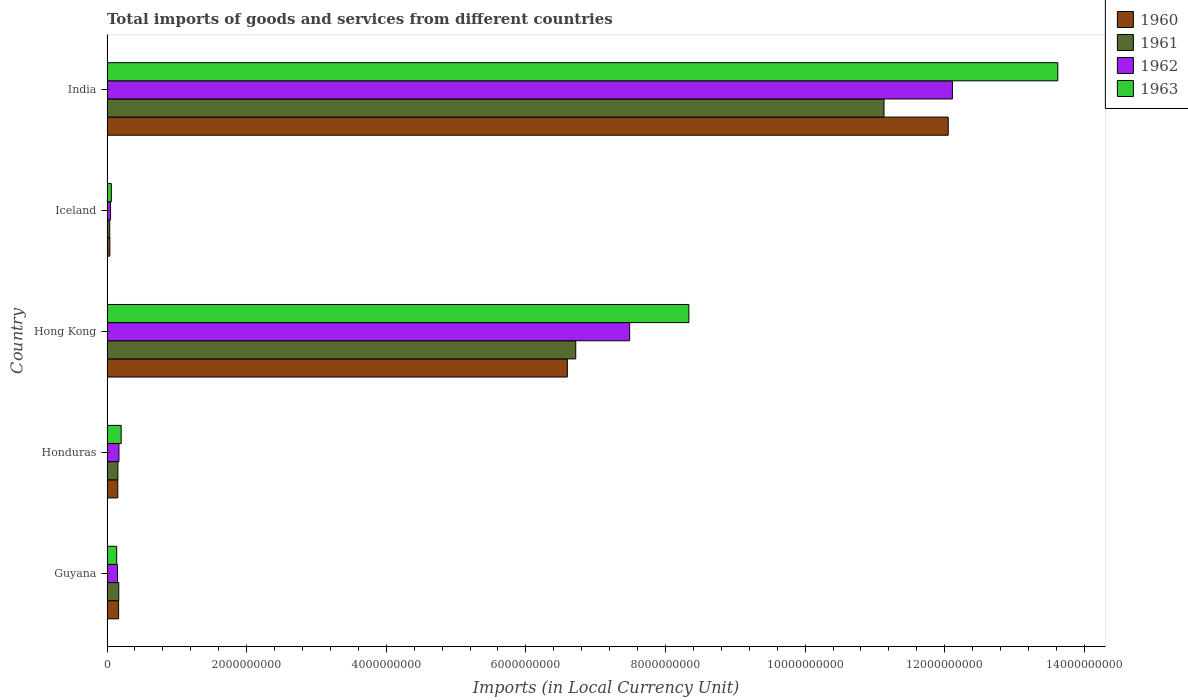How many groups of bars are there?
Offer a terse response. 5. Are the number of bars per tick equal to the number of legend labels?
Offer a very short reply. Yes. How many bars are there on the 2nd tick from the top?
Your response must be concise. 4. What is the label of the 5th group of bars from the top?
Offer a very short reply. Guyana. What is the Amount of goods and services imports in 1961 in Honduras?
Offer a terse response. 1.56e+08. Across all countries, what is the maximum Amount of goods and services imports in 1962?
Your response must be concise. 1.21e+1. Across all countries, what is the minimum Amount of goods and services imports in 1960?
Make the answer very short. 4.10e+07. In which country was the Amount of goods and services imports in 1962 maximum?
Your answer should be compact. India. What is the total Amount of goods and services imports in 1962 in the graph?
Keep it short and to the point. 2.00e+1. What is the difference between the Amount of goods and services imports in 1962 in Honduras and that in Iceland?
Your response must be concise. 1.20e+08. What is the difference between the Amount of goods and services imports in 1960 in Guyana and the Amount of goods and services imports in 1961 in Hong Kong?
Offer a terse response. -6.55e+09. What is the average Amount of goods and services imports in 1960 per country?
Offer a very short reply. 3.80e+09. What is the difference between the Amount of goods and services imports in 1962 and Amount of goods and services imports in 1963 in Honduras?
Offer a terse response. -3.16e+07. What is the ratio of the Amount of goods and services imports in 1963 in Hong Kong to that in India?
Give a very brief answer. 0.61. Is the Amount of goods and services imports in 1963 in Hong Kong less than that in India?
Provide a short and direct response. Yes. Is the difference between the Amount of goods and services imports in 1962 in Honduras and Iceland greater than the difference between the Amount of goods and services imports in 1963 in Honduras and Iceland?
Your answer should be very brief. No. What is the difference between the highest and the second highest Amount of goods and services imports in 1961?
Ensure brevity in your answer.  4.42e+09. What is the difference between the highest and the lowest Amount of goods and services imports in 1960?
Your answer should be compact. 1.20e+1. Is it the case that in every country, the sum of the Amount of goods and services imports in 1963 and Amount of goods and services imports in 1961 is greater than the sum of Amount of goods and services imports in 1962 and Amount of goods and services imports in 1960?
Ensure brevity in your answer.  No. What does the 4th bar from the bottom in Iceland represents?
Your response must be concise. 1963. Are the values on the major ticks of X-axis written in scientific E-notation?
Your response must be concise. No. Does the graph contain any zero values?
Ensure brevity in your answer.  No. Does the graph contain grids?
Your answer should be very brief. No. Where does the legend appear in the graph?
Offer a very short reply. Top right. How many legend labels are there?
Make the answer very short. 4. How are the legend labels stacked?
Provide a succinct answer. Vertical. What is the title of the graph?
Give a very brief answer. Total imports of goods and services from different countries. What is the label or title of the X-axis?
Provide a succinct answer. Imports (in Local Currency Unit). What is the label or title of the Y-axis?
Your response must be concise. Country. What is the Imports (in Local Currency Unit) of 1960 in Guyana?
Provide a succinct answer. 1.66e+08. What is the Imports (in Local Currency Unit) in 1961 in Guyana?
Your response must be concise. 1.69e+08. What is the Imports (in Local Currency Unit) in 1962 in Guyana?
Offer a very short reply. 1.50e+08. What is the Imports (in Local Currency Unit) in 1963 in Guyana?
Your response must be concise. 1.39e+08. What is the Imports (in Local Currency Unit) of 1960 in Honduras?
Make the answer very short. 1.55e+08. What is the Imports (in Local Currency Unit) of 1961 in Honduras?
Make the answer very short. 1.56e+08. What is the Imports (in Local Currency Unit) of 1962 in Honduras?
Offer a very short reply. 1.71e+08. What is the Imports (in Local Currency Unit) in 1963 in Honduras?
Keep it short and to the point. 2.03e+08. What is the Imports (in Local Currency Unit) of 1960 in Hong Kong?
Provide a short and direct response. 6.59e+09. What is the Imports (in Local Currency Unit) of 1961 in Hong Kong?
Give a very brief answer. 6.71e+09. What is the Imports (in Local Currency Unit) of 1962 in Hong Kong?
Your answer should be compact. 7.49e+09. What is the Imports (in Local Currency Unit) of 1963 in Hong Kong?
Your answer should be compact. 8.34e+09. What is the Imports (in Local Currency Unit) of 1960 in Iceland?
Give a very brief answer. 4.10e+07. What is the Imports (in Local Currency Unit) in 1961 in Iceland?
Offer a very short reply. 3.90e+07. What is the Imports (in Local Currency Unit) in 1962 in Iceland?
Give a very brief answer. 5.09e+07. What is the Imports (in Local Currency Unit) of 1963 in Iceland?
Keep it short and to the point. 6.19e+07. What is the Imports (in Local Currency Unit) in 1960 in India?
Your answer should be very brief. 1.20e+1. What is the Imports (in Local Currency Unit) in 1961 in India?
Your answer should be very brief. 1.11e+1. What is the Imports (in Local Currency Unit) of 1962 in India?
Give a very brief answer. 1.21e+1. What is the Imports (in Local Currency Unit) in 1963 in India?
Your answer should be very brief. 1.36e+1. Across all countries, what is the maximum Imports (in Local Currency Unit) of 1960?
Ensure brevity in your answer.  1.20e+1. Across all countries, what is the maximum Imports (in Local Currency Unit) of 1961?
Give a very brief answer. 1.11e+1. Across all countries, what is the maximum Imports (in Local Currency Unit) of 1962?
Your response must be concise. 1.21e+1. Across all countries, what is the maximum Imports (in Local Currency Unit) of 1963?
Provide a short and direct response. 1.36e+1. Across all countries, what is the minimum Imports (in Local Currency Unit) in 1960?
Your response must be concise. 4.10e+07. Across all countries, what is the minimum Imports (in Local Currency Unit) of 1961?
Offer a terse response. 3.90e+07. Across all countries, what is the minimum Imports (in Local Currency Unit) of 1962?
Offer a very short reply. 5.09e+07. Across all countries, what is the minimum Imports (in Local Currency Unit) of 1963?
Provide a short and direct response. 6.19e+07. What is the total Imports (in Local Currency Unit) in 1960 in the graph?
Offer a terse response. 1.90e+1. What is the total Imports (in Local Currency Unit) in 1961 in the graph?
Ensure brevity in your answer.  1.82e+1. What is the total Imports (in Local Currency Unit) of 1962 in the graph?
Offer a very short reply. 2.00e+1. What is the total Imports (in Local Currency Unit) of 1963 in the graph?
Ensure brevity in your answer.  2.24e+1. What is the difference between the Imports (in Local Currency Unit) in 1960 in Guyana and that in Honduras?
Make the answer very short. 1.16e+07. What is the difference between the Imports (in Local Currency Unit) of 1961 in Guyana and that in Honduras?
Give a very brief answer. 1.26e+07. What is the difference between the Imports (in Local Currency Unit) in 1962 in Guyana and that in Honduras?
Make the answer very short. -2.12e+07. What is the difference between the Imports (in Local Currency Unit) of 1963 in Guyana and that in Honduras?
Make the answer very short. -6.38e+07. What is the difference between the Imports (in Local Currency Unit) in 1960 in Guyana and that in Hong Kong?
Offer a terse response. -6.43e+09. What is the difference between the Imports (in Local Currency Unit) in 1961 in Guyana and that in Hong Kong?
Ensure brevity in your answer.  -6.55e+09. What is the difference between the Imports (in Local Currency Unit) in 1962 in Guyana and that in Hong Kong?
Your answer should be very brief. -7.34e+09. What is the difference between the Imports (in Local Currency Unit) in 1963 in Guyana and that in Hong Kong?
Your answer should be very brief. -8.20e+09. What is the difference between the Imports (in Local Currency Unit) in 1960 in Guyana and that in Iceland?
Your answer should be compact. 1.25e+08. What is the difference between the Imports (in Local Currency Unit) of 1961 in Guyana and that in Iceland?
Offer a very short reply. 1.30e+08. What is the difference between the Imports (in Local Currency Unit) of 1962 in Guyana and that in Iceland?
Give a very brief answer. 9.91e+07. What is the difference between the Imports (in Local Currency Unit) of 1963 in Guyana and that in Iceland?
Give a very brief answer. 7.71e+07. What is the difference between the Imports (in Local Currency Unit) of 1960 in Guyana and that in India?
Give a very brief answer. -1.19e+1. What is the difference between the Imports (in Local Currency Unit) in 1961 in Guyana and that in India?
Offer a very short reply. -1.10e+1. What is the difference between the Imports (in Local Currency Unit) in 1962 in Guyana and that in India?
Offer a very short reply. -1.20e+1. What is the difference between the Imports (in Local Currency Unit) of 1963 in Guyana and that in India?
Provide a succinct answer. -1.35e+1. What is the difference between the Imports (in Local Currency Unit) in 1960 in Honduras and that in Hong Kong?
Make the answer very short. -6.44e+09. What is the difference between the Imports (in Local Currency Unit) of 1961 in Honduras and that in Hong Kong?
Keep it short and to the point. -6.56e+09. What is the difference between the Imports (in Local Currency Unit) in 1962 in Honduras and that in Hong Kong?
Your answer should be compact. -7.32e+09. What is the difference between the Imports (in Local Currency Unit) of 1963 in Honduras and that in Hong Kong?
Your answer should be compact. -8.13e+09. What is the difference between the Imports (in Local Currency Unit) in 1960 in Honduras and that in Iceland?
Offer a very short reply. 1.14e+08. What is the difference between the Imports (in Local Currency Unit) in 1961 in Honduras and that in Iceland?
Your response must be concise. 1.17e+08. What is the difference between the Imports (in Local Currency Unit) in 1962 in Honduras and that in Iceland?
Keep it short and to the point. 1.20e+08. What is the difference between the Imports (in Local Currency Unit) in 1963 in Honduras and that in Iceland?
Your answer should be very brief. 1.41e+08. What is the difference between the Imports (in Local Currency Unit) in 1960 in Honduras and that in India?
Ensure brevity in your answer.  -1.19e+1. What is the difference between the Imports (in Local Currency Unit) of 1961 in Honduras and that in India?
Your response must be concise. -1.10e+1. What is the difference between the Imports (in Local Currency Unit) in 1962 in Honduras and that in India?
Ensure brevity in your answer.  -1.19e+1. What is the difference between the Imports (in Local Currency Unit) in 1963 in Honduras and that in India?
Make the answer very short. -1.34e+1. What is the difference between the Imports (in Local Currency Unit) of 1960 in Hong Kong and that in Iceland?
Make the answer very short. 6.55e+09. What is the difference between the Imports (in Local Currency Unit) in 1961 in Hong Kong and that in Iceland?
Give a very brief answer. 6.68e+09. What is the difference between the Imports (in Local Currency Unit) in 1962 in Hong Kong and that in Iceland?
Your answer should be compact. 7.44e+09. What is the difference between the Imports (in Local Currency Unit) of 1963 in Hong Kong and that in Iceland?
Your answer should be compact. 8.27e+09. What is the difference between the Imports (in Local Currency Unit) in 1960 in Hong Kong and that in India?
Your answer should be compact. -5.46e+09. What is the difference between the Imports (in Local Currency Unit) in 1961 in Hong Kong and that in India?
Keep it short and to the point. -4.42e+09. What is the difference between the Imports (in Local Currency Unit) in 1962 in Hong Kong and that in India?
Make the answer very short. -4.62e+09. What is the difference between the Imports (in Local Currency Unit) of 1963 in Hong Kong and that in India?
Your response must be concise. -5.28e+09. What is the difference between the Imports (in Local Currency Unit) in 1960 in Iceland and that in India?
Keep it short and to the point. -1.20e+1. What is the difference between the Imports (in Local Currency Unit) of 1961 in Iceland and that in India?
Ensure brevity in your answer.  -1.11e+1. What is the difference between the Imports (in Local Currency Unit) of 1962 in Iceland and that in India?
Give a very brief answer. -1.21e+1. What is the difference between the Imports (in Local Currency Unit) of 1963 in Iceland and that in India?
Your answer should be compact. -1.36e+1. What is the difference between the Imports (in Local Currency Unit) of 1960 in Guyana and the Imports (in Local Currency Unit) of 1961 in Honduras?
Your answer should be compact. 1.00e+07. What is the difference between the Imports (in Local Currency Unit) of 1960 in Guyana and the Imports (in Local Currency Unit) of 1962 in Honduras?
Keep it short and to the point. -5.00e+06. What is the difference between the Imports (in Local Currency Unit) of 1960 in Guyana and the Imports (in Local Currency Unit) of 1963 in Honduras?
Offer a terse response. -3.66e+07. What is the difference between the Imports (in Local Currency Unit) in 1961 in Guyana and the Imports (in Local Currency Unit) in 1962 in Honduras?
Your response must be concise. -2.40e+06. What is the difference between the Imports (in Local Currency Unit) in 1961 in Guyana and the Imports (in Local Currency Unit) in 1963 in Honduras?
Give a very brief answer. -3.40e+07. What is the difference between the Imports (in Local Currency Unit) in 1962 in Guyana and the Imports (in Local Currency Unit) in 1963 in Honduras?
Offer a very short reply. -5.28e+07. What is the difference between the Imports (in Local Currency Unit) of 1960 in Guyana and the Imports (in Local Currency Unit) of 1961 in Hong Kong?
Offer a terse response. -6.55e+09. What is the difference between the Imports (in Local Currency Unit) in 1960 in Guyana and the Imports (in Local Currency Unit) in 1962 in Hong Kong?
Your answer should be very brief. -7.32e+09. What is the difference between the Imports (in Local Currency Unit) in 1960 in Guyana and the Imports (in Local Currency Unit) in 1963 in Hong Kong?
Your answer should be very brief. -8.17e+09. What is the difference between the Imports (in Local Currency Unit) in 1961 in Guyana and the Imports (in Local Currency Unit) in 1962 in Hong Kong?
Offer a very short reply. -7.32e+09. What is the difference between the Imports (in Local Currency Unit) of 1961 in Guyana and the Imports (in Local Currency Unit) of 1963 in Hong Kong?
Ensure brevity in your answer.  -8.17e+09. What is the difference between the Imports (in Local Currency Unit) of 1962 in Guyana and the Imports (in Local Currency Unit) of 1963 in Hong Kong?
Your answer should be very brief. -8.19e+09. What is the difference between the Imports (in Local Currency Unit) in 1960 in Guyana and the Imports (in Local Currency Unit) in 1961 in Iceland?
Keep it short and to the point. 1.27e+08. What is the difference between the Imports (in Local Currency Unit) of 1960 in Guyana and the Imports (in Local Currency Unit) of 1962 in Iceland?
Offer a very short reply. 1.15e+08. What is the difference between the Imports (in Local Currency Unit) in 1960 in Guyana and the Imports (in Local Currency Unit) in 1963 in Iceland?
Give a very brief answer. 1.04e+08. What is the difference between the Imports (in Local Currency Unit) of 1961 in Guyana and the Imports (in Local Currency Unit) of 1962 in Iceland?
Your answer should be compact. 1.18e+08. What is the difference between the Imports (in Local Currency Unit) in 1961 in Guyana and the Imports (in Local Currency Unit) in 1963 in Iceland?
Your answer should be very brief. 1.07e+08. What is the difference between the Imports (in Local Currency Unit) in 1962 in Guyana and the Imports (in Local Currency Unit) in 1963 in Iceland?
Give a very brief answer. 8.81e+07. What is the difference between the Imports (in Local Currency Unit) in 1960 in Guyana and the Imports (in Local Currency Unit) in 1961 in India?
Provide a succinct answer. -1.10e+1. What is the difference between the Imports (in Local Currency Unit) in 1960 in Guyana and the Imports (in Local Currency Unit) in 1962 in India?
Your answer should be compact. -1.19e+1. What is the difference between the Imports (in Local Currency Unit) in 1960 in Guyana and the Imports (in Local Currency Unit) in 1963 in India?
Your answer should be compact. -1.35e+1. What is the difference between the Imports (in Local Currency Unit) of 1961 in Guyana and the Imports (in Local Currency Unit) of 1962 in India?
Give a very brief answer. -1.19e+1. What is the difference between the Imports (in Local Currency Unit) of 1961 in Guyana and the Imports (in Local Currency Unit) of 1963 in India?
Provide a succinct answer. -1.35e+1. What is the difference between the Imports (in Local Currency Unit) of 1962 in Guyana and the Imports (in Local Currency Unit) of 1963 in India?
Make the answer very short. -1.35e+1. What is the difference between the Imports (in Local Currency Unit) of 1960 in Honduras and the Imports (in Local Currency Unit) of 1961 in Hong Kong?
Ensure brevity in your answer.  -6.56e+09. What is the difference between the Imports (in Local Currency Unit) in 1960 in Honduras and the Imports (in Local Currency Unit) in 1962 in Hong Kong?
Keep it short and to the point. -7.33e+09. What is the difference between the Imports (in Local Currency Unit) in 1960 in Honduras and the Imports (in Local Currency Unit) in 1963 in Hong Kong?
Keep it short and to the point. -8.18e+09. What is the difference between the Imports (in Local Currency Unit) of 1961 in Honduras and the Imports (in Local Currency Unit) of 1962 in Hong Kong?
Make the answer very short. -7.33e+09. What is the difference between the Imports (in Local Currency Unit) of 1961 in Honduras and the Imports (in Local Currency Unit) of 1963 in Hong Kong?
Offer a very short reply. -8.18e+09. What is the difference between the Imports (in Local Currency Unit) of 1962 in Honduras and the Imports (in Local Currency Unit) of 1963 in Hong Kong?
Offer a terse response. -8.16e+09. What is the difference between the Imports (in Local Currency Unit) of 1960 in Honduras and the Imports (in Local Currency Unit) of 1961 in Iceland?
Your answer should be very brief. 1.16e+08. What is the difference between the Imports (in Local Currency Unit) of 1960 in Honduras and the Imports (in Local Currency Unit) of 1962 in Iceland?
Give a very brief answer. 1.04e+08. What is the difference between the Imports (in Local Currency Unit) of 1960 in Honduras and the Imports (in Local Currency Unit) of 1963 in Iceland?
Your response must be concise. 9.27e+07. What is the difference between the Imports (in Local Currency Unit) in 1961 in Honduras and the Imports (in Local Currency Unit) in 1962 in Iceland?
Your answer should be compact. 1.05e+08. What is the difference between the Imports (in Local Currency Unit) of 1961 in Honduras and the Imports (in Local Currency Unit) of 1963 in Iceland?
Make the answer very short. 9.43e+07. What is the difference between the Imports (in Local Currency Unit) in 1962 in Honduras and the Imports (in Local Currency Unit) in 1963 in Iceland?
Keep it short and to the point. 1.09e+08. What is the difference between the Imports (in Local Currency Unit) in 1960 in Honduras and the Imports (in Local Currency Unit) in 1961 in India?
Offer a terse response. -1.10e+1. What is the difference between the Imports (in Local Currency Unit) in 1960 in Honduras and the Imports (in Local Currency Unit) in 1962 in India?
Keep it short and to the point. -1.20e+1. What is the difference between the Imports (in Local Currency Unit) of 1960 in Honduras and the Imports (in Local Currency Unit) of 1963 in India?
Provide a succinct answer. -1.35e+1. What is the difference between the Imports (in Local Currency Unit) in 1961 in Honduras and the Imports (in Local Currency Unit) in 1962 in India?
Your answer should be very brief. -1.20e+1. What is the difference between the Imports (in Local Currency Unit) in 1961 in Honduras and the Imports (in Local Currency Unit) in 1963 in India?
Keep it short and to the point. -1.35e+1. What is the difference between the Imports (in Local Currency Unit) of 1962 in Honduras and the Imports (in Local Currency Unit) of 1963 in India?
Keep it short and to the point. -1.34e+1. What is the difference between the Imports (in Local Currency Unit) of 1960 in Hong Kong and the Imports (in Local Currency Unit) of 1961 in Iceland?
Ensure brevity in your answer.  6.56e+09. What is the difference between the Imports (in Local Currency Unit) of 1960 in Hong Kong and the Imports (in Local Currency Unit) of 1962 in Iceland?
Provide a succinct answer. 6.54e+09. What is the difference between the Imports (in Local Currency Unit) in 1960 in Hong Kong and the Imports (in Local Currency Unit) in 1963 in Iceland?
Your answer should be compact. 6.53e+09. What is the difference between the Imports (in Local Currency Unit) of 1961 in Hong Kong and the Imports (in Local Currency Unit) of 1962 in Iceland?
Your response must be concise. 6.66e+09. What is the difference between the Imports (in Local Currency Unit) of 1961 in Hong Kong and the Imports (in Local Currency Unit) of 1963 in Iceland?
Offer a terse response. 6.65e+09. What is the difference between the Imports (in Local Currency Unit) of 1962 in Hong Kong and the Imports (in Local Currency Unit) of 1963 in Iceland?
Your response must be concise. 7.42e+09. What is the difference between the Imports (in Local Currency Unit) in 1960 in Hong Kong and the Imports (in Local Currency Unit) in 1961 in India?
Provide a short and direct response. -4.54e+09. What is the difference between the Imports (in Local Currency Unit) of 1960 in Hong Kong and the Imports (in Local Currency Unit) of 1962 in India?
Provide a short and direct response. -5.52e+09. What is the difference between the Imports (in Local Currency Unit) of 1960 in Hong Kong and the Imports (in Local Currency Unit) of 1963 in India?
Offer a terse response. -7.03e+09. What is the difference between the Imports (in Local Currency Unit) of 1961 in Hong Kong and the Imports (in Local Currency Unit) of 1962 in India?
Offer a very short reply. -5.40e+09. What is the difference between the Imports (in Local Currency Unit) of 1961 in Hong Kong and the Imports (in Local Currency Unit) of 1963 in India?
Make the answer very short. -6.91e+09. What is the difference between the Imports (in Local Currency Unit) in 1962 in Hong Kong and the Imports (in Local Currency Unit) in 1963 in India?
Your answer should be compact. -6.13e+09. What is the difference between the Imports (in Local Currency Unit) in 1960 in Iceland and the Imports (in Local Currency Unit) in 1961 in India?
Your answer should be very brief. -1.11e+1. What is the difference between the Imports (in Local Currency Unit) of 1960 in Iceland and the Imports (in Local Currency Unit) of 1962 in India?
Provide a succinct answer. -1.21e+1. What is the difference between the Imports (in Local Currency Unit) of 1960 in Iceland and the Imports (in Local Currency Unit) of 1963 in India?
Keep it short and to the point. -1.36e+1. What is the difference between the Imports (in Local Currency Unit) of 1961 in Iceland and the Imports (in Local Currency Unit) of 1962 in India?
Offer a terse response. -1.21e+1. What is the difference between the Imports (in Local Currency Unit) in 1961 in Iceland and the Imports (in Local Currency Unit) in 1963 in India?
Give a very brief answer. -1.36e+1. What is the difference between the Imports (in Local Currency Unit) of 1962 in Iceland and the Imports (in Local Currency Unit) of 1963 in India?
Give a very brief answer. -1.36e+1. What is the average Imports (in Local Currency Unit) of 1960 per country?
Provide a succinct answer. 3.80e+09. What is the average Imports (in Local Currency Unit) of 1961 per country?
Your response must be concise. 3.64e+09. What is the average Imports (in Local Currency Unit) in 1962 per country?
Provide a short and direct response. 3.99e+09. What is the average Imports (in Local Currency Unit) in 1963 per country?
Give a very brief answer. 4.47e+09. What is the difference between the Imports (in Local Currency Unit) in 1960 and Imports (in Local Currency Unit) in 1961 in Guyana?
Provide a succinct answer. -2.60e+06. What is the difference between the Imports (in Local Currency Unit) of 1960 and Imports (in Local Currency Unit) of 1962 in Guyana?
Make the answer very short. 1.62e+07. What is the difference between the Imports (in Local Currency Unit) in 1960 and Imports (in Local Currency Unit) in 1963 in Guyana?
Make the answer very short. 2.72e+07. What is the difference between the Imports (in Local Currency Unit) in 1961 and Imports (in Local Currency Unit) in 1962 in Guyana?
Offer a very short reply. 1.88e+07. What is the difference between the Imports (in Local Currency Unit) of 1961 and Imports (in Local Currency Unit) of 1963 in Guyana?
Offer a very short reply. 2.98e+07. What is the difference between the Imports (in Local Currency Unit) of 1962 and Imports (in Local Currency Unit) of 1963 in Guyana?
Give a very brief answer. 1.10e+07. What is the difference between the Imports (in Local Currency Unit) in 1960 and Imports (in Local Currency Unit) in 1961 in Honduras?
Your answer should be compact. -1.60e+06. What is the difference between the Imports (in Local Currency Unit) of 1960 and Imports (in Local Currency Unit) of 1962 in Honduras?
Keep it short and to the point. -1.66e+07. What is the difference between the Imports (in Local Currency Unit) in 1960 and Imports (in Local Currency Unit) in 1963 in Honduras?
Your answer should be compact. -4.82e+07. What is the difference between the Imports (in Local Currency Unit) in 1961 and Imports (in Local Currency Unit) in 1962 in Honduras?
Keep it short and to the point. -1.50e+07. What is the difference between the Imports (in Local Currency Unit) of 1961 and Imports (in Local Currency Unit) of 1963 in Honduras?
Ensure brevity in your answer.  -4.66e+07. What is the difference between the Imports (in Local Currency Unit) in 1962 and Imports (in Local Currency Unit) in 1963 in Honduras?
Offer a very short reply. -3.16e+07. What is the difference between the Imports (in Local Currency Unit) of 1960 and Imports (in Local Currency Unit) of 1961 in Hong Kong?
Keep it short and to the point. -1.20e+08. What is the difference between the Imports (in Local Currency Unit) of 1960 and Imports (in Local Currency Unit) of 1962 in Hong Kong?
Offer a very short reply. -8.92e+08. What is the difference between the Imports (in Local Currency Unit) of 1960 and Imports (in Local Currency Unit) of 1963 in Hong Kong?
Your response must be concise. -1.74e+09. What is the difference between the Imports (in Local Currency Unit) of 1961 and Imports (in Local Currency Unit) of 1962 in Hong Kong?
Your response must be concise. -7.72e+08. What is the difference between the Imports (in Local Currency Unit) of 1961 and Imports (in Local Currency Unit) of 1963 in Hong Kong?
Keep it short and to the point. -1.62e+09. What is the difference between the Imports (in Local Currency Unit) of 1962 and Imports (in Local Currency Unit) of 1963 in Hong Kong?
Your answer should be compact. -8.49e+08. What is the difference between the Imports (in Local Currency Unit) in 1960 and Imports (in Local Currency Unit) in 1961 in Iceland?
Provide a short and direct response. 2.00e+06. What is the difference between the Imports (in Local Currency Unit) in 1960 and Imports (in Local Currency Unit) in 1962 in Iceland?
Offer a very short reply. -9.99e+06. What is the difference between the Imports (in Local Currency Unit) of 1960 and Imports (in Local Currency Unit) of 1963 in Iceland?
Keep it short and to the point. -2.10e+07. What is the difference between the Imports (in Local Currency Unit) of 1961 and Imports (in Local Currency Unit) of 1962 in Iceland?
Provide a succinct answer. -1.20e+07. What is the difference between the Imports (in Local Currency Unit) of 1961 and Imports (in Local Currency Unit) of 1963 in Iceland?
Give a very brief answer. -2.30e+07. What is the difference between the Imports (in Local Currency Unit) of 1962 and Imports (in Local Currency Unit) of 1963 in Iceland?
Provide a succinct answer. -1.10e+07. What is the difference between the Imports (in Local Currency Unit) of 1960 and Imports (in Local Currency Unit) of 1961 in India?
Give a very brief answer. 9.20e+08. What is the difference between the Imports (in Local Currency Unit) in 1960 and Imports (in Local Currency Unit) in 1962 in India?
Provide a succinct answer. -6.00e+07. What is the difference between the Imports (in Local Currency Unit) of 1960 and Imports (in Local Currency Unit) of 1963 in India?
Make the answer very short. -1.57e+09. What is the difference between the Imports (in Local Currency Unit) of 1961 and Imports (in Local Currency Unit) of 1962 in India?
Give a very brief answer. -9.80e+08. What is the difference between the Imports (in Local Currency Unit) in 1961 and Imports (in Local Currency Unit) in 1963 in India?
Your response must be concise. -2.49e+09. What is the difference between the Imports (in Local Currency Unit) of 1962 and Imports (in Local Currency Unit) of 1963 in India?
Offer a terse response. -1.51e+09. What is the ratio of the Imports (in Local Currency Unit) in 1960 in Guyana to that in Honduras?
Offer a very short reply. 1.07. What is the ratio of the Imports (in Local Currency Unit) in 1961 in Guyana to that in Honduras?
Keep it short and to the point. 1.08. What is the ratio of the Imports (in Local Currency Unit) of 1962 in Guyana to that in Honduras?
Your answer should be very brief. 0.88. What is the ratio of the Imports (in Local Currency Unit) in 1963 in Guyana to that in Honduras?
Offer a terse response. 0.69. What is the ratio of the Imports (in Local Currency Unit) in 1960 in Guyana to that in Hong Kong?
Provide a short and direct response. 0.03. What is the ratio of the Imports (in Local Currency Unit) in 1961 in Guyana to that in Hong Kong?
Your response must be concise. 0.03. What is the ratio of the Imports (in Local Currency Unit) of 1962 in Guyana to that in Hong Kong?
Offer a terse response. 0.02. What is the ratio of the Imports (in Local Currency Unit) in 1963 in Guyana to that in Hong Kong?
Your answer should be very brief. 0.02. What is the ratio of the Imports (in Local Currency Unit) in 1960 in Guyana to that in Iceland?
Your answer should be compact. 4.06. What is the ratio of the Imports (in Local Currency Unit) in 1961 in Guyana to that in Iceland?
Provide a succinct answer. 4.33. What is the ratio of the Imports (in Local Currency Unit) of 1962 in Guyana to that in Iceland?
Offer a terse response. 2.94. What is the ratio of the Imports (in Local Currency Unit) in 1963 in Guyana to that in Iceland?
Offer a very short reply. 2.24. What is the ratio of the Imports (in Local Currency Unit) of 1960 in Guyana to that in India?
Give a very brief answer. 0.01. What is the ratio of the Imports (in Local Currency Unit) of 1961 in Guyana to that in India?
Provide a succinct answer. 0.02. What is the ratio of the Imports (in Local Currency Unit) in 1962 in Guyana to that in India?
Provide a succinct answer. 0.01. What is the ratio of the Imports (in Local Currency Unit) in 1963 in Guyana to that in India?
Provide a short and direct response. 0.01. What is the ratio of the Imports (in Local Currency Unit) of 1960 in Honduras to that in Hong Kong?
Offer a very short reply. 0.02. What is the ratio of the Imports (in Local Currency Unit) of 1961 in Honduras to that in Hong Kong?
Your answer should be very brief. 0.02. What is the ratio of the Imports (in Local Currency Unit) of 1962 in Honduras to that in Hong Kong?
Your answer should be compact. 0.02. What is the ratio of the Imports (in Local Currency Unit) in 1963 in Honduras to that in Hong Kong?
Make the answer very short. 0.02. What is the ratio of the Imports (in Local Currency Unit) in 1960 in Honduras to that in Iceland?
Your answer should be compact. 3.77. What is the ratio of the Imports (in Local Currency Unit) in 1961 in Honduras to that in Iceland?
Offer a terse response. 4.01. What is the ratio of the Imports (in Local Currency Unit) in 1962 in Honduras to that in Iceland?
Offer a terse response. 3.36. What is the ratio of the Imports (in Local Currency Unit) of 1963 in Honduras to that in Iceland?
Your answer should be very brief. 3.27. What is the ratio of the Imports (in Local Currency Unit) of 1960 in Honduras to that in India?
Offer a very short reply. 0.01. What is the ratio of the Imports (in Local Currency Unit) of 1961 in Honduras to that in India?
Ensure brevity in your answer.  0.01. What is the ratio of the Imports (in Local Currency Unit) of 1962 in Honduras to that in India?
Give a very brief answer. 0.01. What is the ratio of the Imports (in Local Currency Unit) of 1963 in Honduras to that in India?
Give a very brief answer. 0.01. What is the ratio of the Imports (in Local Currency Unit) of 1960 in Hong Kong to that in Iceland?
Make the answer very short. 161. What is the ratio of the Imports (in Local Currency Unit) in 1961 in Hong Kong to that in Iceland?
Provide a short and direct response. 172.35. What is the ratio of the Imports (in Local Currency Unit) of 1962 in Hong Kong to that in Iceland?
Keep it short and to the point. 146.95. What is the ratio of the Imports (in Local Currency Unit) in 1963 in Hong Kong to that in Iceland?
Ensure brevity in your answer.  134.58. What is the ratio of the Imports (in Local Currency Unit) of 1960 in Hong Kong to that in India?
Ensure brevity in your answer.  0.55. What is the ratio of the Imports (in Local Currency Unit) in 1961 in Hong Kong to that in India?
Ensure brevity in your answer.  0.6. What is the ratio of the Imports (in Local Currency Unit) in 1962 in Hong Kong to that in India?
Provide a succinct answer. 0.62. What is the ratio of the Imports (in Local Currency Unit) in 1963 in Hong Kong to that in India?
Provide a succinct answer. 0.61. What is the ratio of the Imports (in Local Currency Unit) of 1960 in Iceland to that in India?
Your answer should be very brief. 0. What is the ratio of the Imports (in Local Currency Unit) in 1961 in Iceland to that in India?
Offer a terse response. 0. What is the ratio of the Imports (in Local Currency Unit) of 1962 in Iceland to that in India?
Provide a succinct answer. 0. What is the ratio of the Imports (in Local Currency Unit) in 1963 in Iceland to that in India?
Offer a terse response. 0. What is the difference between the highest and the second highest Imports (in Local Currency Unit) of 1960?
Provide a succinct answer. 5.46e+09. What is the difference between the highest and the second highest Imports (in Local Currency Unit) in 1961?
Offer a very short reply. 4.42e+09. What is the difference between the highest and the second highest Imports (in Local Currency Unit) of 1962?
Ensure brevity in your answer.  4.62e+09. What is the difference between the highest and the second highest Imports (in Local Currency Unit) in 1963?
Your answer should be compact. 5.28e+09. What is the difference between the highest and the lowest Imports (in Local Currency Unit) of 1960?
Offer a terse response. 1.20e+1. What is the difference between the highest and the lowest Imports (in Local Currency Unit) of 1961?
Your answer should be very brief. 1.11e+1. What is the difference between the highest and the lowest Imports (in Local Currency Unit) in 1962?
Ensure brevity in your answer.  1.21e+1. What is the difference between the highest and the lowest Imports (in Local Currency Unit) of 1963?
Your answer should be very brief. 1.36e+1. 